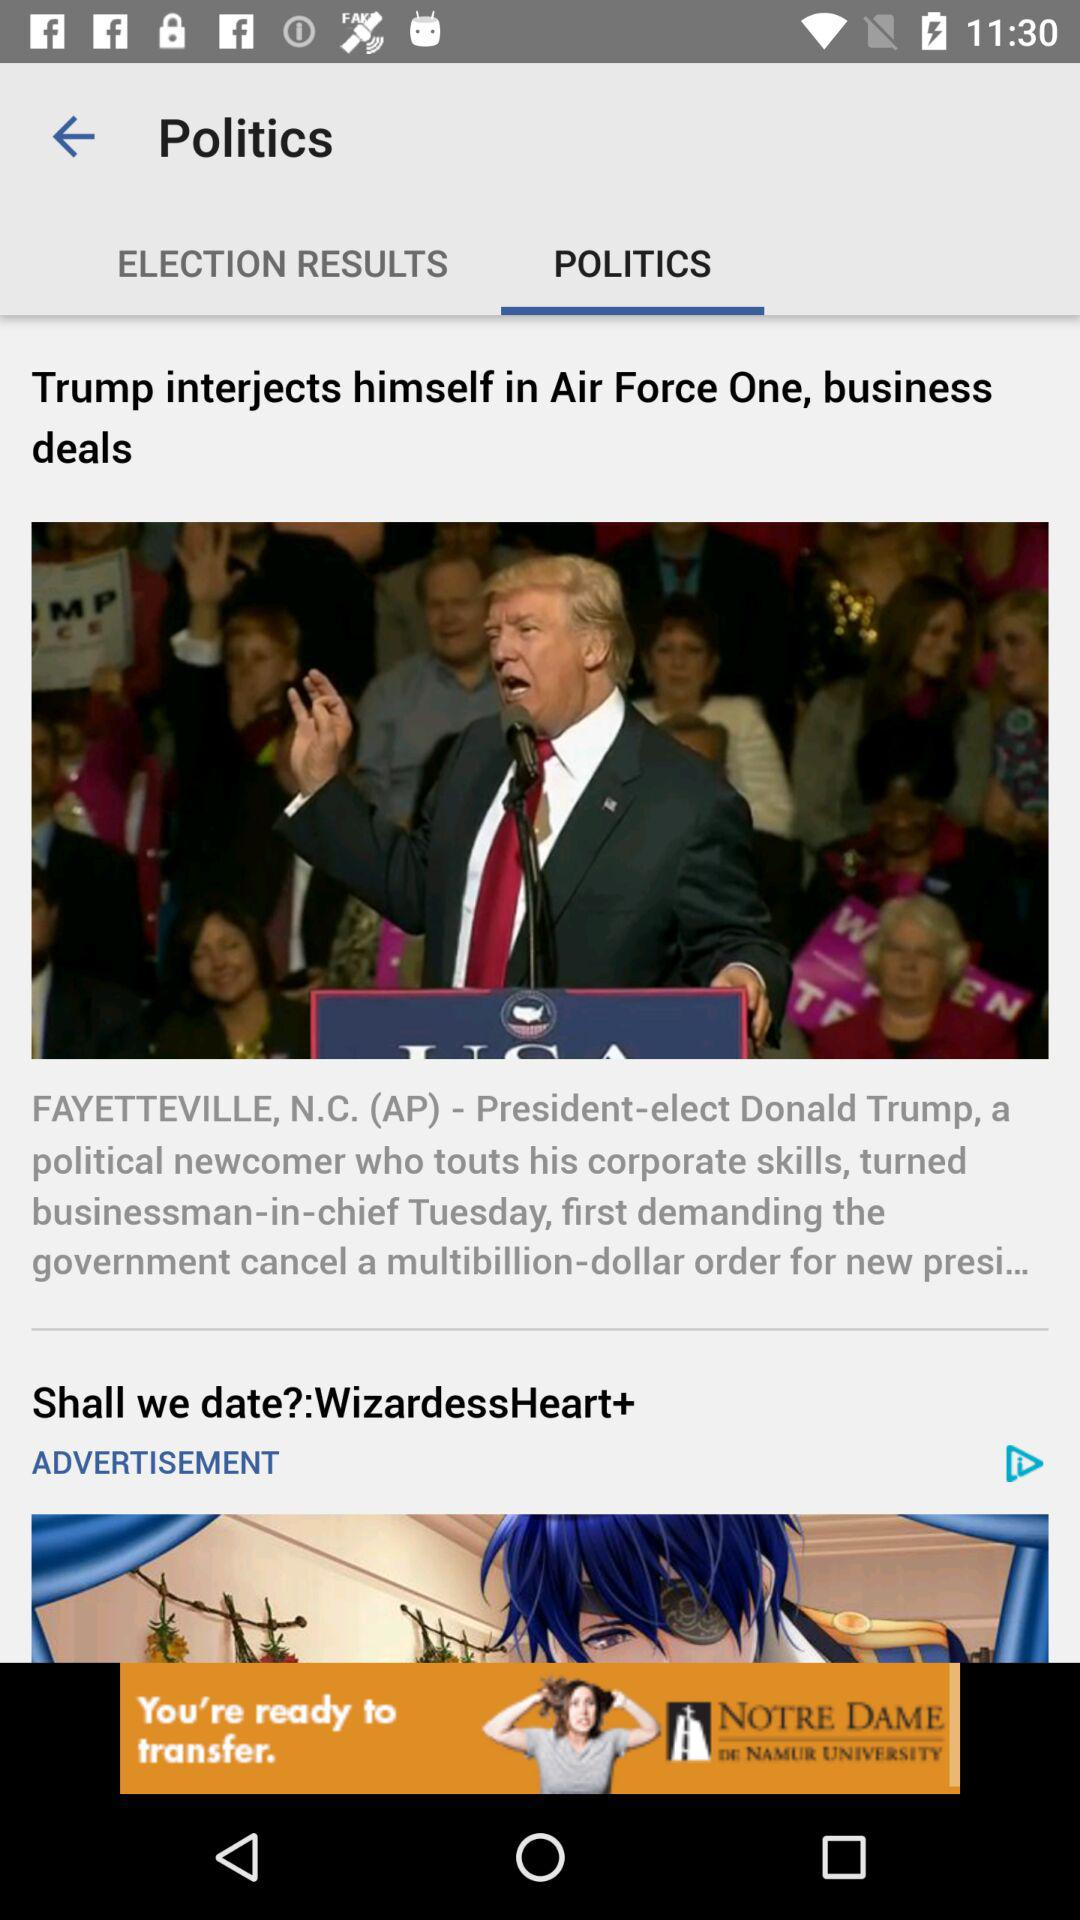Which tab is open? The open tab is "POLITICS". 